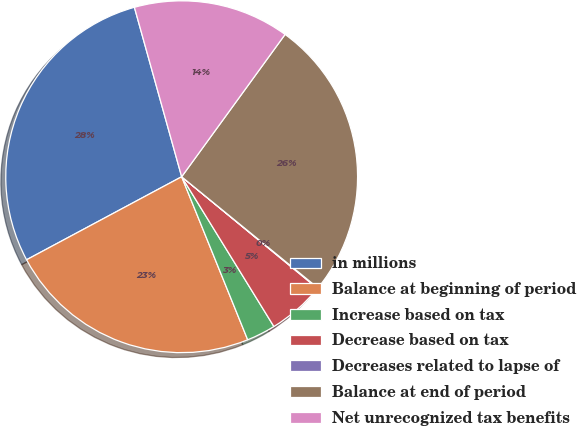<chart> <loc_0><loc_0><loc_500><loc_500><pie_chart><fcel>in millions<fcel>Balance at beginning of period<fcel>Increase based on tax<fcel>Decrease based on tax<fcel>Decreases related to lapse of<fcel>Balance at end of period<fcel>Net unrecognized tax benefits<nl><fcel>28.49%<fcel>23.3%<fcel>2.66%<fcel>5.26%<fcel>0.06%<fcel>25.89%<fcel>14.33%<nl></chart> 